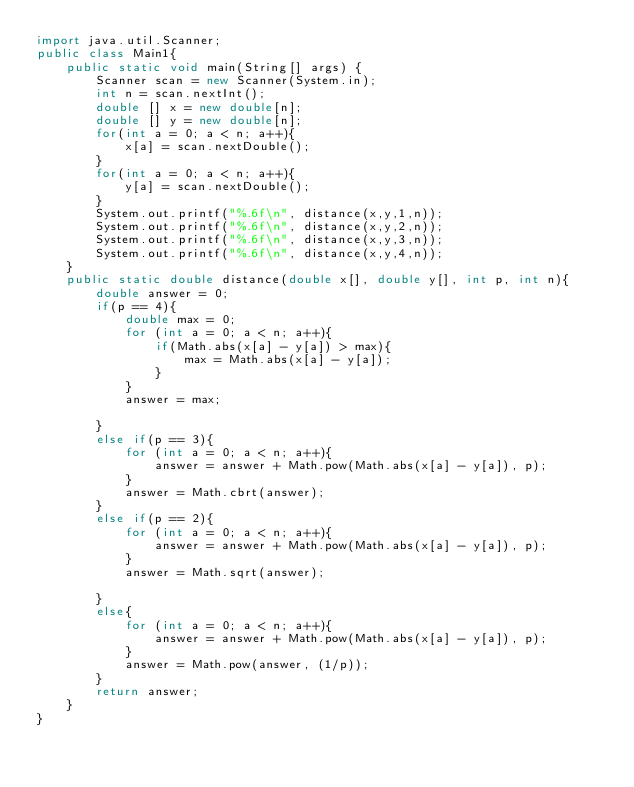<code> <loc_0><loc_0><loc_500><loc_500><_Java_>import java.util.Scanner;
public class Main1{
    public static void main(String[] args) {
        Scanner scan = new Scanner(System.in);
        int n = scan.nextInt();
        double [] x = new double[n];
        double [] y = new double[n];
        for(int a = 0; a < n; a++){
            x[a] = scan.nextDouble();
        }
        for(int a = 0; a < n; a++){
            y[a] = scan.nextDouble();
        }
        System.out.printf("%.6f\n", distance(x,y,1,n));
        System.out.printf("%.6f\n", distance(x,y,2,n));
        System.out.printf("%.6f\n", distance(x,y,3,n));
        System.out.printf("%.6f\n", distance(x,y,4,n));
    }
    public static double distance(double x[], double y[], int p, int n){
        double answer = 0;
        if(p == 4){
            double max = 0;
            for (int a = 0; a < n; a++){
                if(Math.abs(x[a] - y[a]) > max){
                    max = Math.abs(x[a] - y[a]);
                }
            }
            answer = max;

        }
        else if(p == 3){
            for (int a = 0; a < n; a++){
                answer = answer + Math.pow(Math.abs(x[a] - y[a]), p);
            }
            answer = Math.cbrt(answer);
        }
        else if(p == 2){
            for (int a = 0; a < n; a++){
                answer = answer + Math.pow(Math.abs(x[a] - y[a]), p);
            }
            answer = Math.sqrt(answer);

        }
        else{
            for (int a = 0; a < n; a++){
                answer = answer + Math.pow(Math.abs(x[a] - y[a]), p);
            }
            answer = Math.pow(answer, (1/p));
        }
        return answer;
    }
}
</code> 